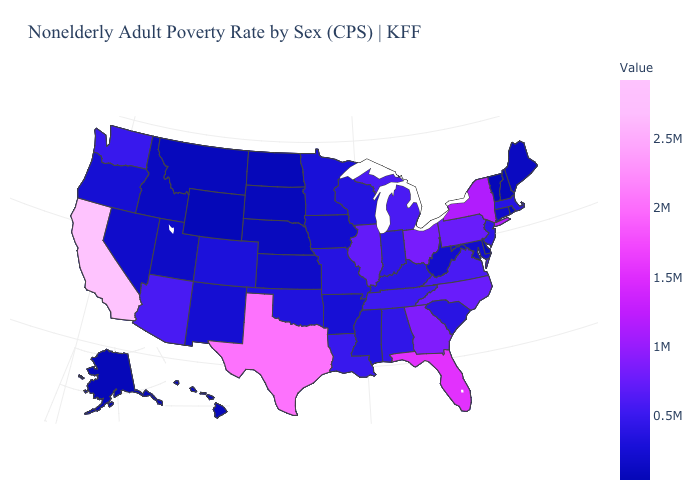Which states have the lowest value in the MidWest?
Quick response, please. North Dakota. Does Michigan have the highest value in the MidWest?
Give a very brief answer. No. Is the legend a continuous bar?
Write a very short answer. Yes. Which states hav the highest value in the MidWest?
Quick response, please. Ohio. 